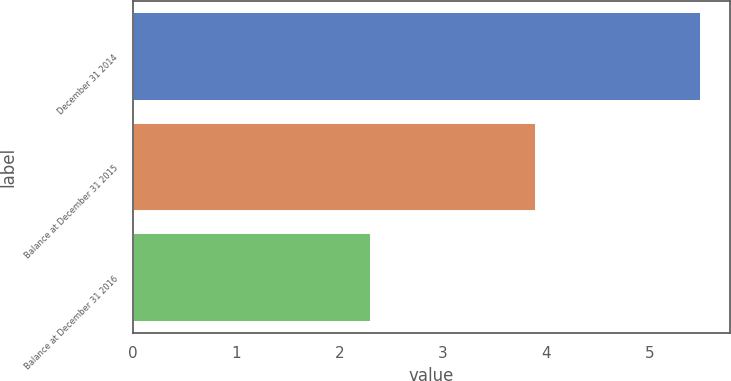Convert chart. <chart><loc_0><loc_0><loc_500><loc_500><bar_chart><fcel>December 31 2014<fcel>Balance at December 31 2015<fcel>Balance at December 31 2016<nl><fcel>5.5<fcel>3.9<fcel>2.3<nl></chart> 